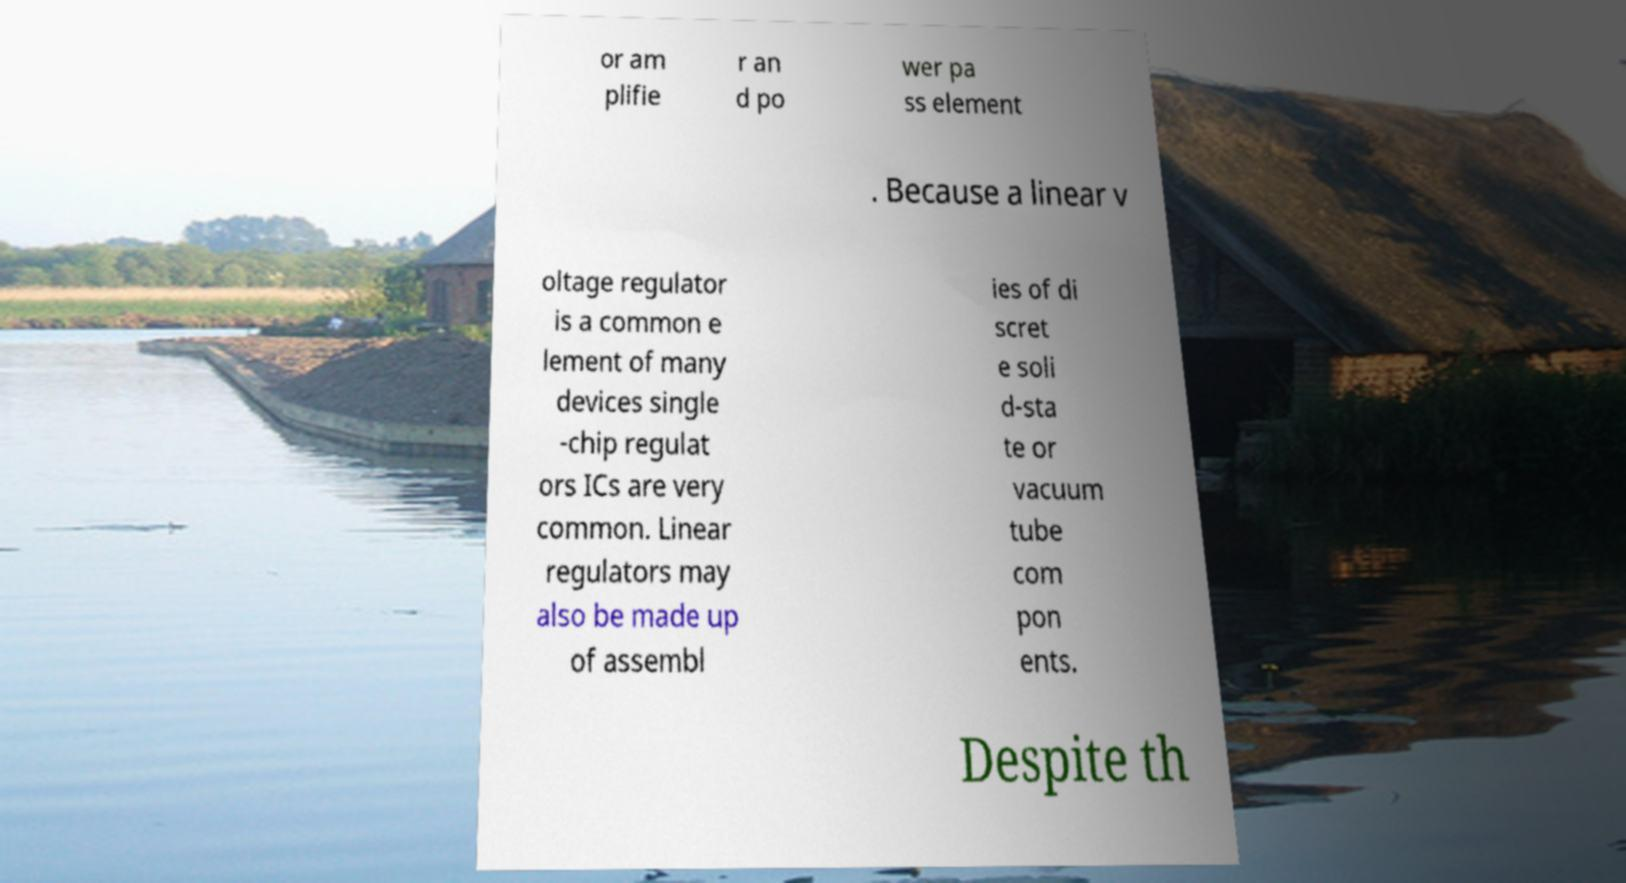Could you extract and type out the text from this image? or am plifie r an d po wer pa ss element . Because a linear v oltage regulator is a common e lement of many devices single -chip regulat ors ICs are very common. Linear regulators may also be made up of assembl ies of di scret e soli d-sta te or vacuum tube com pon ents. Despite th 